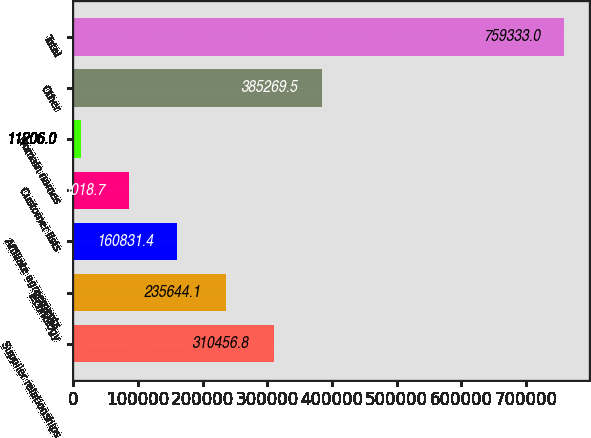Convert chart. <chart><loc_0><loc_0><loc_500><loc_500><bar_chart><fcel>Supplier relationships<fcel>Technology<fcel>Affiliate agreements<fcel>Customer lists<fcel>Domain names<fcel>Other<fcel>Total<nl><fcel>310457<fcel>235644<fcel>160831<fcel>86018.7<fcel>11206<fcel>385270<fcel>759333<nl></chart> 